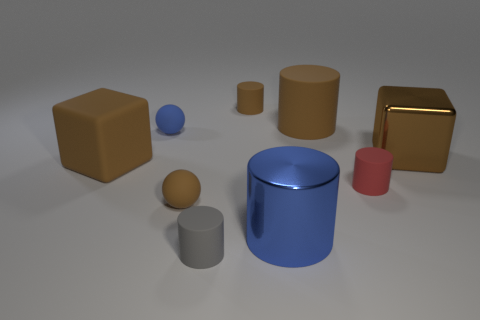Subtract all metal cylinders. How many cylinders are left? 4 Subtract all blue spheres. How many spheres are left? 1 Subtract all balls. How many objects are left? 7 Subtract all cyan cubes. How many blue cylinders are left? 1 Subtract 2 spheres. How many spheres are left? 0 Subtract all red balls. Subtract all red cubes. How many balls are left? 2 Subtract all blue rubber balls. Subtract all large blue metal things. How many objects are left? 7 Add 6 tiny red rubber cylinders. How many tiny red rubber cylinders are left? 7 Add 4 small gray blocks. How many small gray blocks exist? 4 Subtract 0 yellow cubes. How many objects are left? 9 